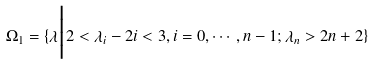Convert formula to latex. <formula><loc_0><loc_0><loc_500><loc_500>\Omega _ { 1 } = \{ \lambda \Big | 2 < \lambda _ { i } - 2 i < 3 , i = 0 , \cdots , n - 1 ; \lambda _ { n } > 2 n + 2 \}</formula> 